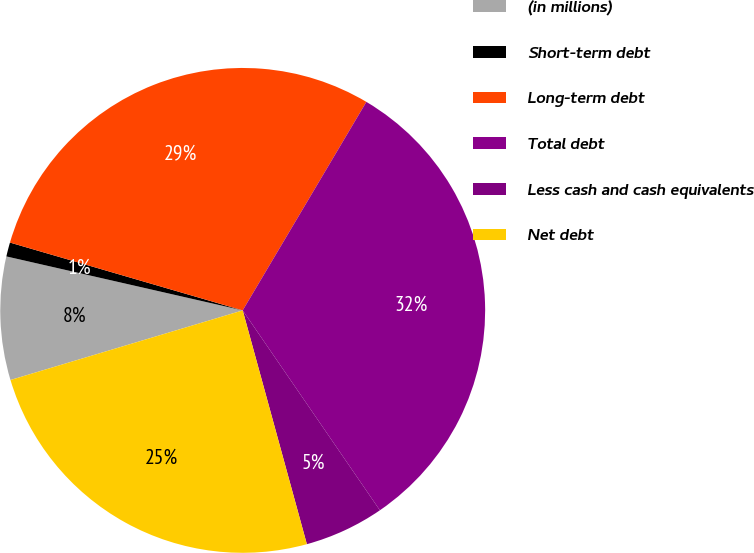Convert chart to OTSL. <chart><loc_0><loc_0><loc_500><loc_500><pie_chart><fcel>(in millions)<fcel>Short-term debt<fcel>Long-term debt<fcel>Total debt<fcel>Less cash and cash equivalents<fcel>Net debt<nl><fcel>8.21%<fcel>0.94%<fcel>29.01%<fcel>31.91%<fcel>5.31%<fcel>24.63%<nl></chart> 